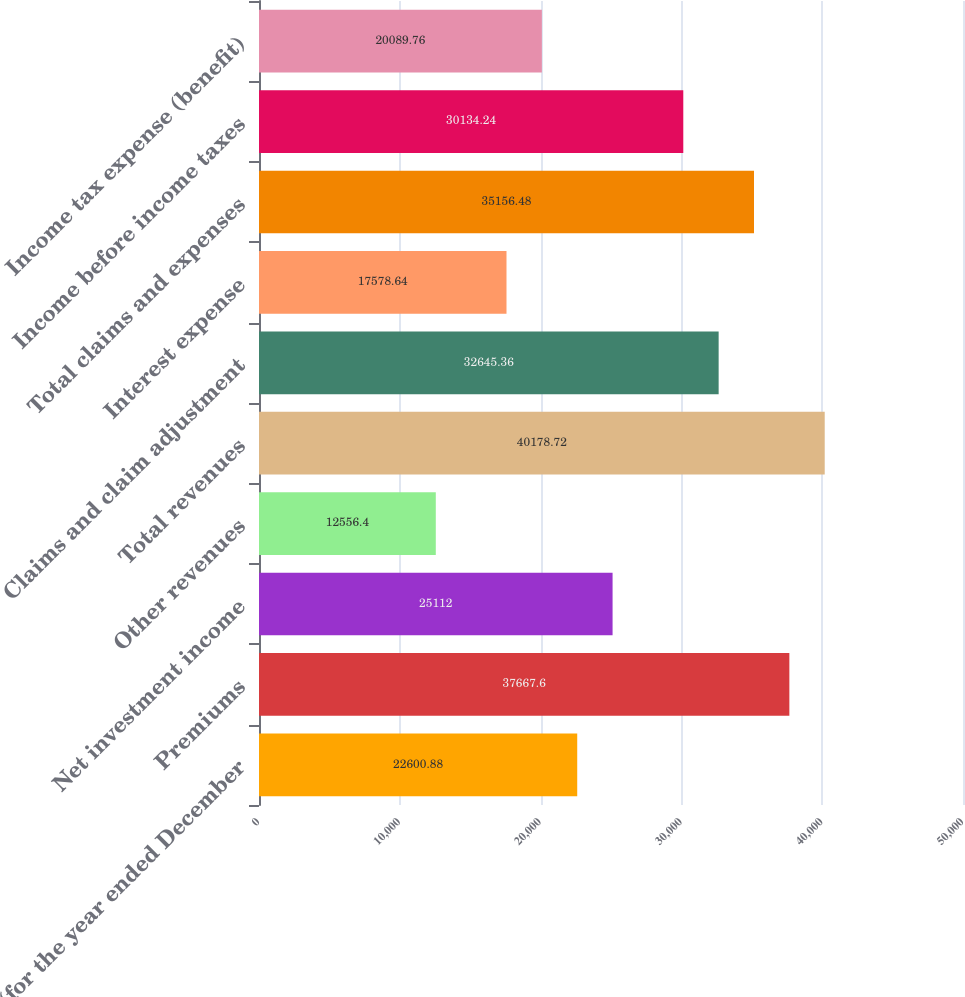Convert chart to OTSL. <chart><loc_0><loc_0><loc_500><loc_500><bar_chart><fcel>(for the year ended December<fcel>Premiums<fcel>Net investment income<fcel>Other revenues<fcel>Total revenues<fcel>Claims and claim adjustment<fcel>Interest expense<fcel>Total claims and expenses<fcel>Income before income taxes<fcel>Income tax expense (benefit)<nl><fcel>22600.9<fcel>37667.6<fcel>25112<fcel>12556.4<fcel>40178.7<fcel>32645.4<fcel>17578.6<fcel>35156.5<fcel>30134.2<fcel>20089.8<nl></chart> 